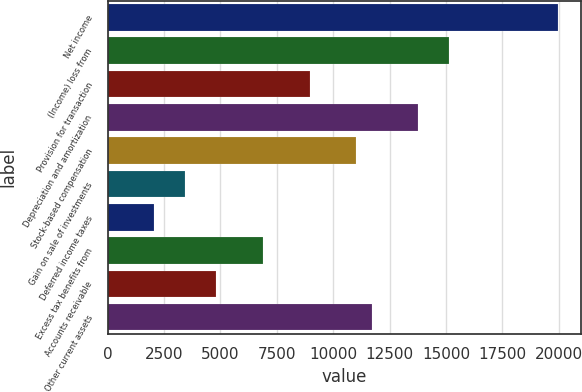Convert chart to OTSL. <chart><loc_0><loc_0><loc_500><loc_500><bar_chart><fcel>Net income<fcel>(Income) loss from<fcel>Provision for transaction<fcel>Depreciation and amortization<fcel>Stock-based compensation<fcel>Gain on sale of investments<fcel>Deferred income taxes<fcel>Excess tax benefits from<fcel>Accounts receivable<fcel>Other current assets<nl><fcel>19974.3<fcel>15153.4<fcel>8955.1<fcel>13776<fcel>11021.2<fcel>3445.5<fcel>2068.1<fcel>6889<fcel>4822.9<fcel>11709.9<nl></chart> 